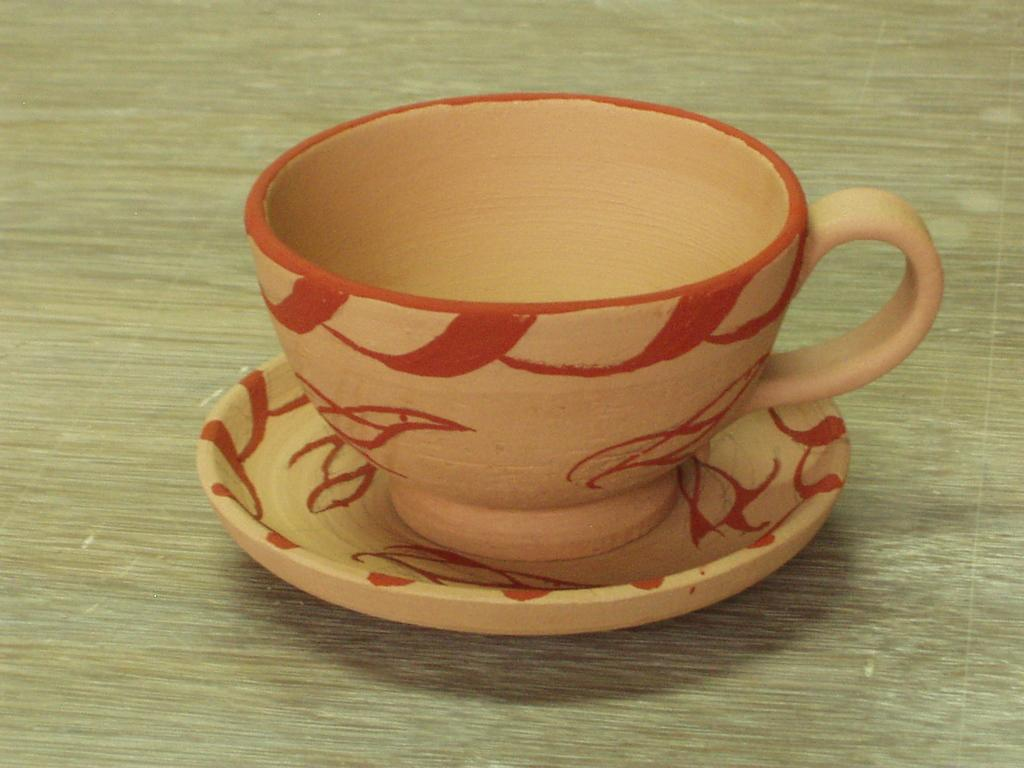What is present in the image that can hold a beverage? There is a cup in the image. What accompanies the cup in the image? There is a saucer in the image. Can you describe the saucer's appearance? The saucer has some designs on it. How many people are attempting to use the cup and saucer in the image? There is no indication of people using or attempting to use the cup and saucer in the image. 